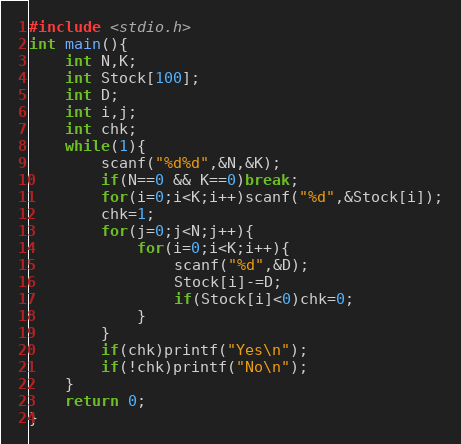Convert code to text. <code><loc_0><loc_0><loc_500><loc_500><_C_>#include <stdio.h>
int main(){
	int N,K;
	int Stock[100];
	int D;
	int i,j;
	int chk;
	while(1){
		scanf("%d%d",&N,&K);
		if(N==0 && K==0)break;
		for(i=0;i<K;i++)scanf("%d",&Stock[i]);
		chk=1;
		for(j=0;j<N;j++){
			for(i=0;i<K;i++){
				scanf("%d",&D);
				Stock[i]-=D;
				if(Stock[i]<0)chk=0;
			}
		}
		if(chk)printf("Yes\n");
		if(!chk)printf("No\n");
	}
	return 0;
}</code> 